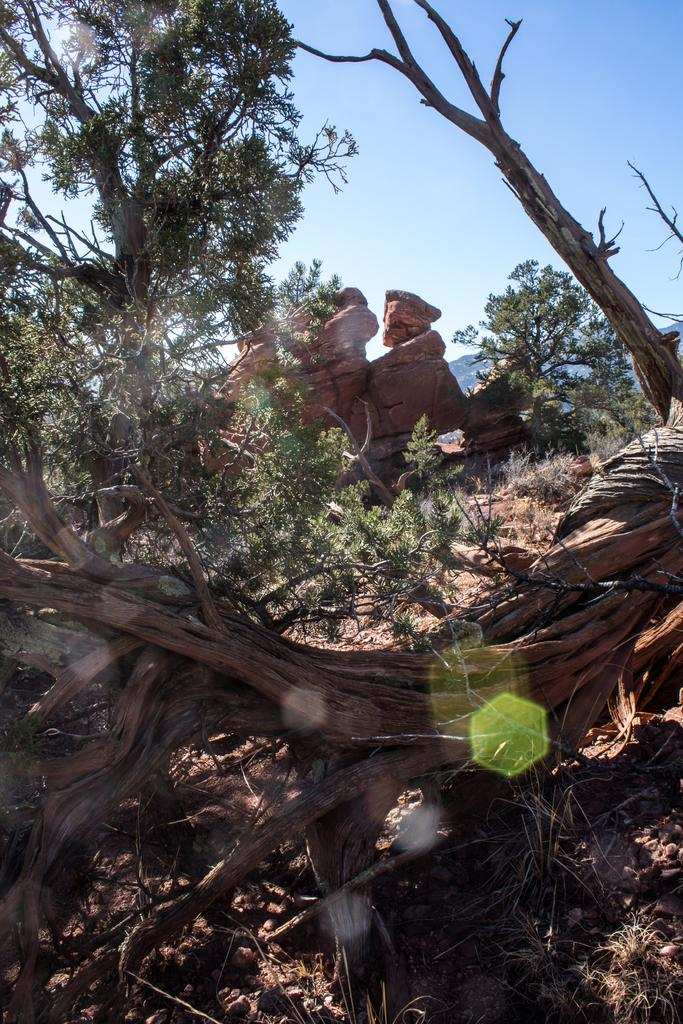What type of natural elements can be seen in the image? There are trees and rocks in the image. What is the color of the sky in the image? The sky is blue in the image. What type of food is being served at the cemetery in the image? There is no cemetery or food present in the image; it features trees, rocks, and a blue sky. 